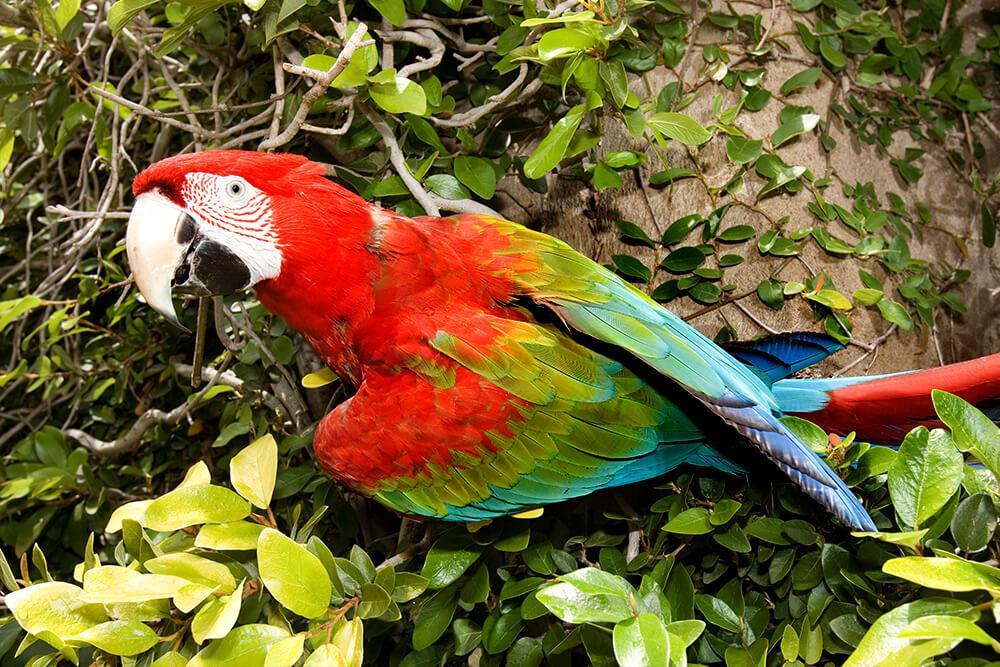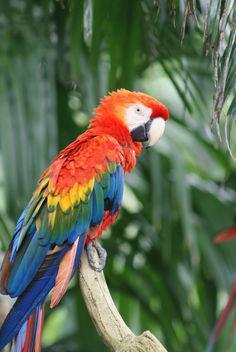The first image is the image on the left, the second image is the image on the right. Analyze the images presented: Is the assertion "The right image contains no more than one parrot." valid? Answer yes or no. Yes. 